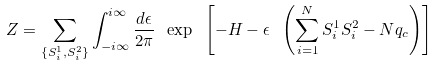Convert formula to latex. <formula><loc_0><loc_0><loc_500><loc_500>Z = \sum _ { \{ S _ { i } ^ { 1 } , S _ { i } ^ { 2 } \} } \int _ { - i \infty } ^ { i \infty } \frac { d \epsilon } { 2 \pi } \ \exp \ \left [ - H - \epsilon \ \left ( \sum _ { i = 1 } ^ { N } S _ { i } ^ { 1 } S _ { i } ^ { 2 } - N \/ q _ { c } \right ) \right ]</formula> 